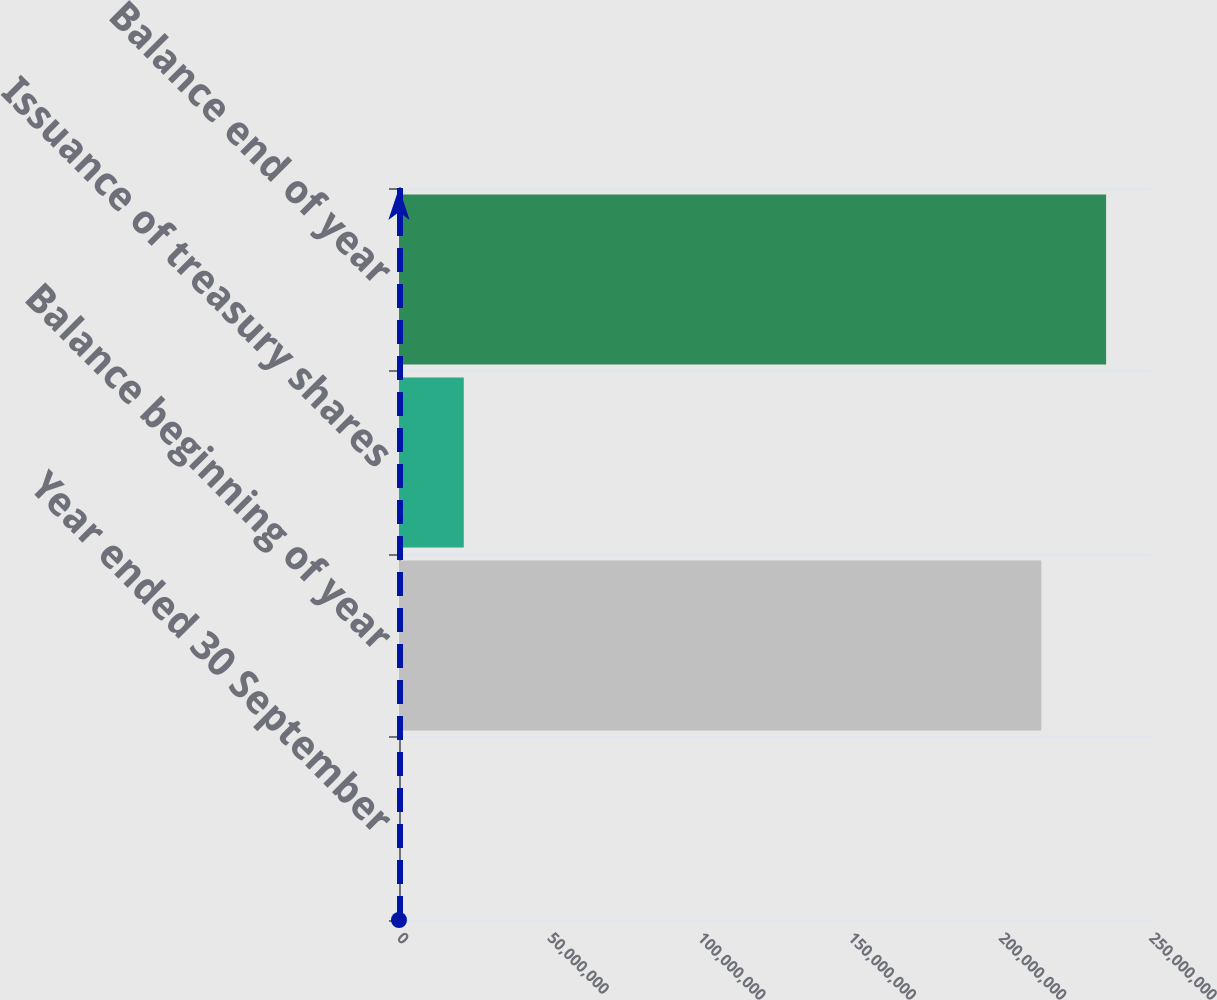<chart> <loc_0><loc_0><loc_500><loc_500><bar_chart><fcel>Year ended 30 September<fcel>Balance beginning of year<fcel>Issuance of treasury shares<fcel>Balance end of year<nl><fcel>2015<fcel>2.13538e+08<fcel>2.15377e+07<fcel>2.35074e+08<nl></chart> 